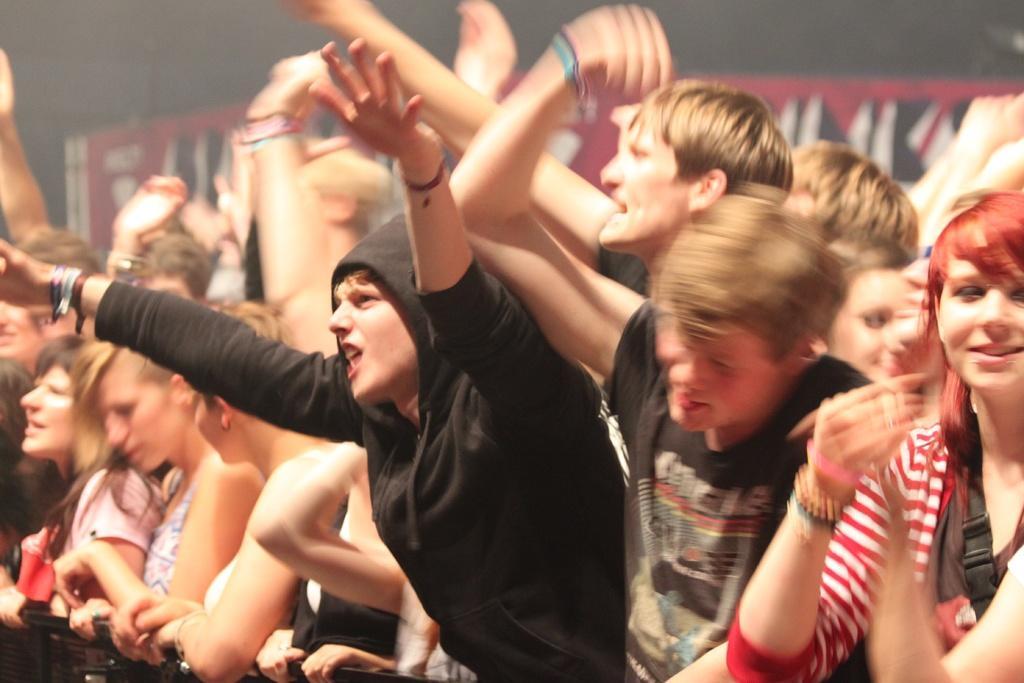Can you describe this image briefly? In this picture we can see a group of people and in the background we can see a poster on the wall. 